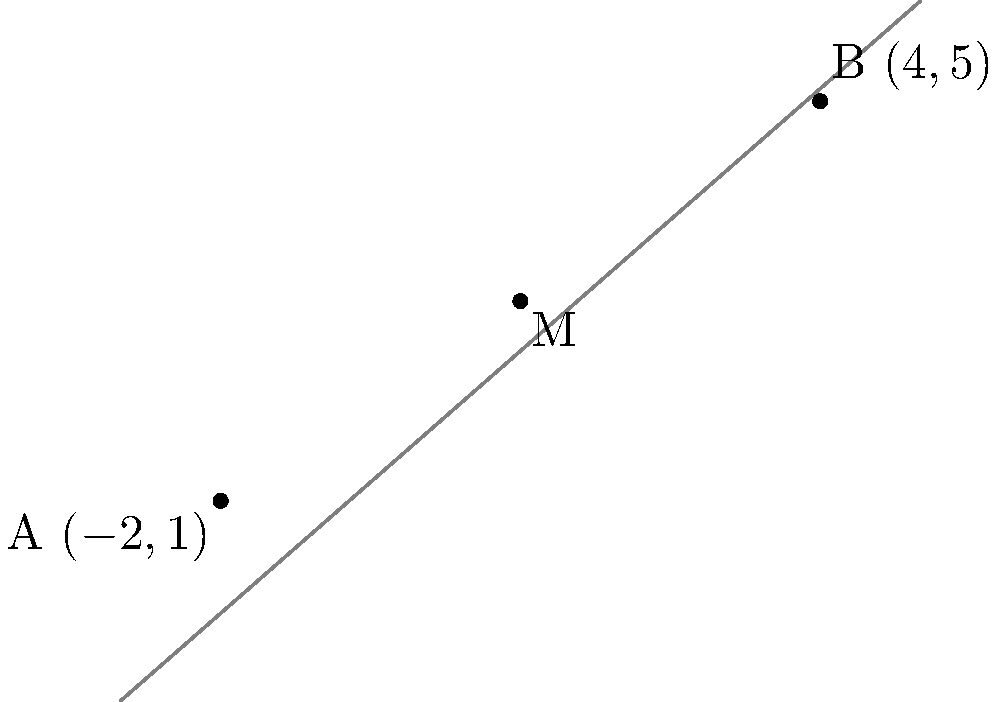In your latest painting, you've decided to explore the concept of balance by incorporating geometric elements. You've placed two significant points on your canvas, representing contrasting emotions: point A at $(-2,1)$ and point B at $(4,5)$. To find the perfect balance between these emotions, you need to locate the midpoint M of the line segment connecting A and B. What are the coordinates of this midpoint M? To find the midpoint M of the line segment connecting points A $(-2,1)$ and B $(4,5)$, we can use the midpoint formula:

$M = (\frac{x_1 + x_2}{2}, \frac{y_1 + y_2}{2})$

Where $(x_1, y_1)$ are the coordinates of point A, and $(x_2, y_2)$ are the coordinates of point B.

Step 1: Identify the coordinates
A: $x_1 = -2$, $y_1 = 1$
B: $x_2 = 4$, $y_2 = 5$

Step 2: Calculate the x-coordinate of the midpoint
$x_M = \frac{x_1 + x_2}{2} = \frac{-2 + 4}{2} = \frac{2}{2} = 1$

Step 3: Calculate the y-coordinate of the midpoint
$y_M = \frac{y_1 + y_2}{2} = \frac{1 + 5}{2} = \frac{6}{2} = 3$

Therefore, the coordinates of the midpoint M are $(1, 3)$.
Answer: $(1, 3)$ 